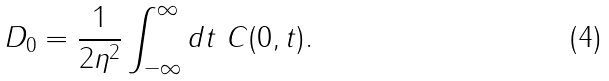<formula> <loc_0><loc_0><loc_500><loc_500>D _ { 0 } = \frac { 1 } { 2 \eta ^ { 2 } } \int _ { - \infty } ^ { \infty } d t \ C ( 0 , t ) .</formula> 